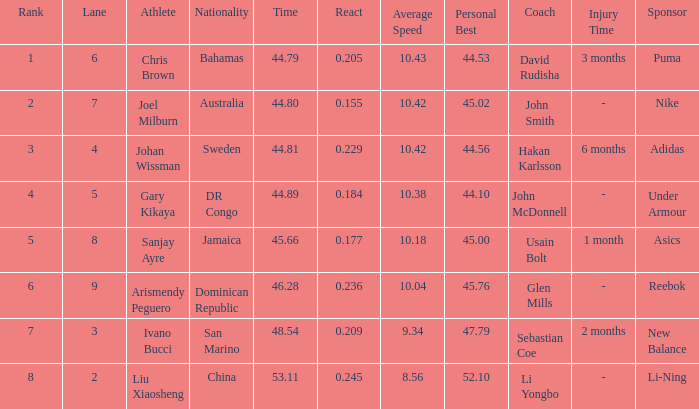How many total Time listings have a 0.209 React entry and a Rank that is greater than 7? 0.0. 